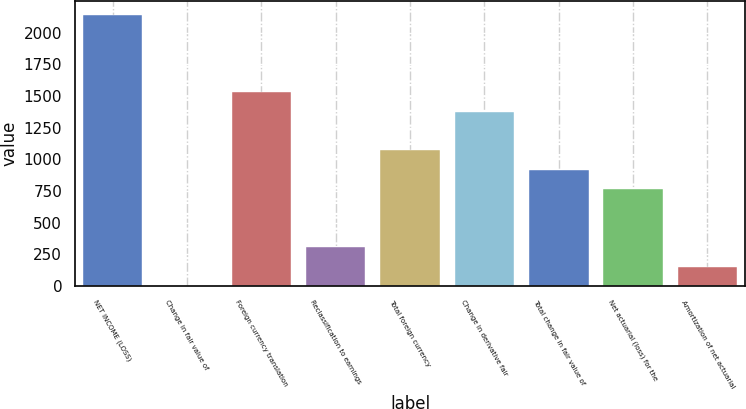Convert chart. <chart><loc_0><loc_0><loc_500><loc_500><bar_chart><fcel>NET INCOME (LOSS)<fcel>Change in fair value of<fcel>Foreign currency translation<fcel>Reclassification to earnings<fcel>Total foreign currency<fcel>Change in derivative fair<fcel>Total change in fair value of<fcel>Net actuarial (loss) for the<fcel>Amortization of net actuarial<nl><fcel>2141.6<fcel>1<fcel>1530<fcel>306.8<fcel>1071.3<fcel>1377.1<fcel>918.4<fcel>765.5<fcel>153.9<nl></chart> 